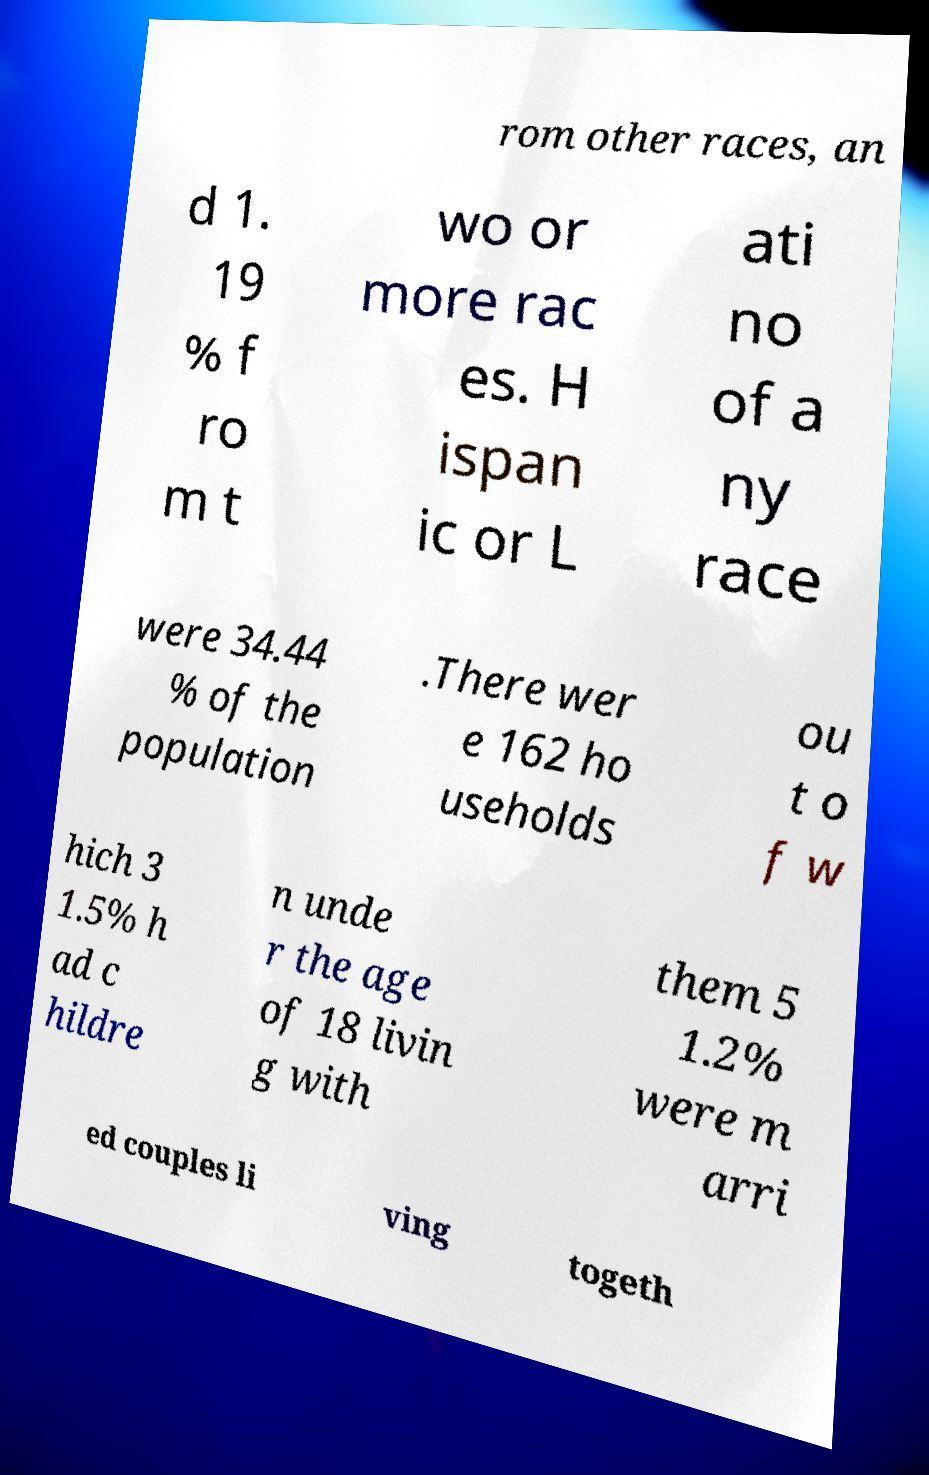What messages or text are displayed in this image? I need them in a readable, typed format. rom other races, an d 1. 19 % f ro m t wo or more rac es. H ispan ic or L ati no of a ny race were 34.44 % of the population .There wer e 162 ho useholds ou t o f w hich 3 1.5% h ad c hildre n unde r the age of 18 livin g with them 5 1.2% were m arri ed couples li ving togeth 